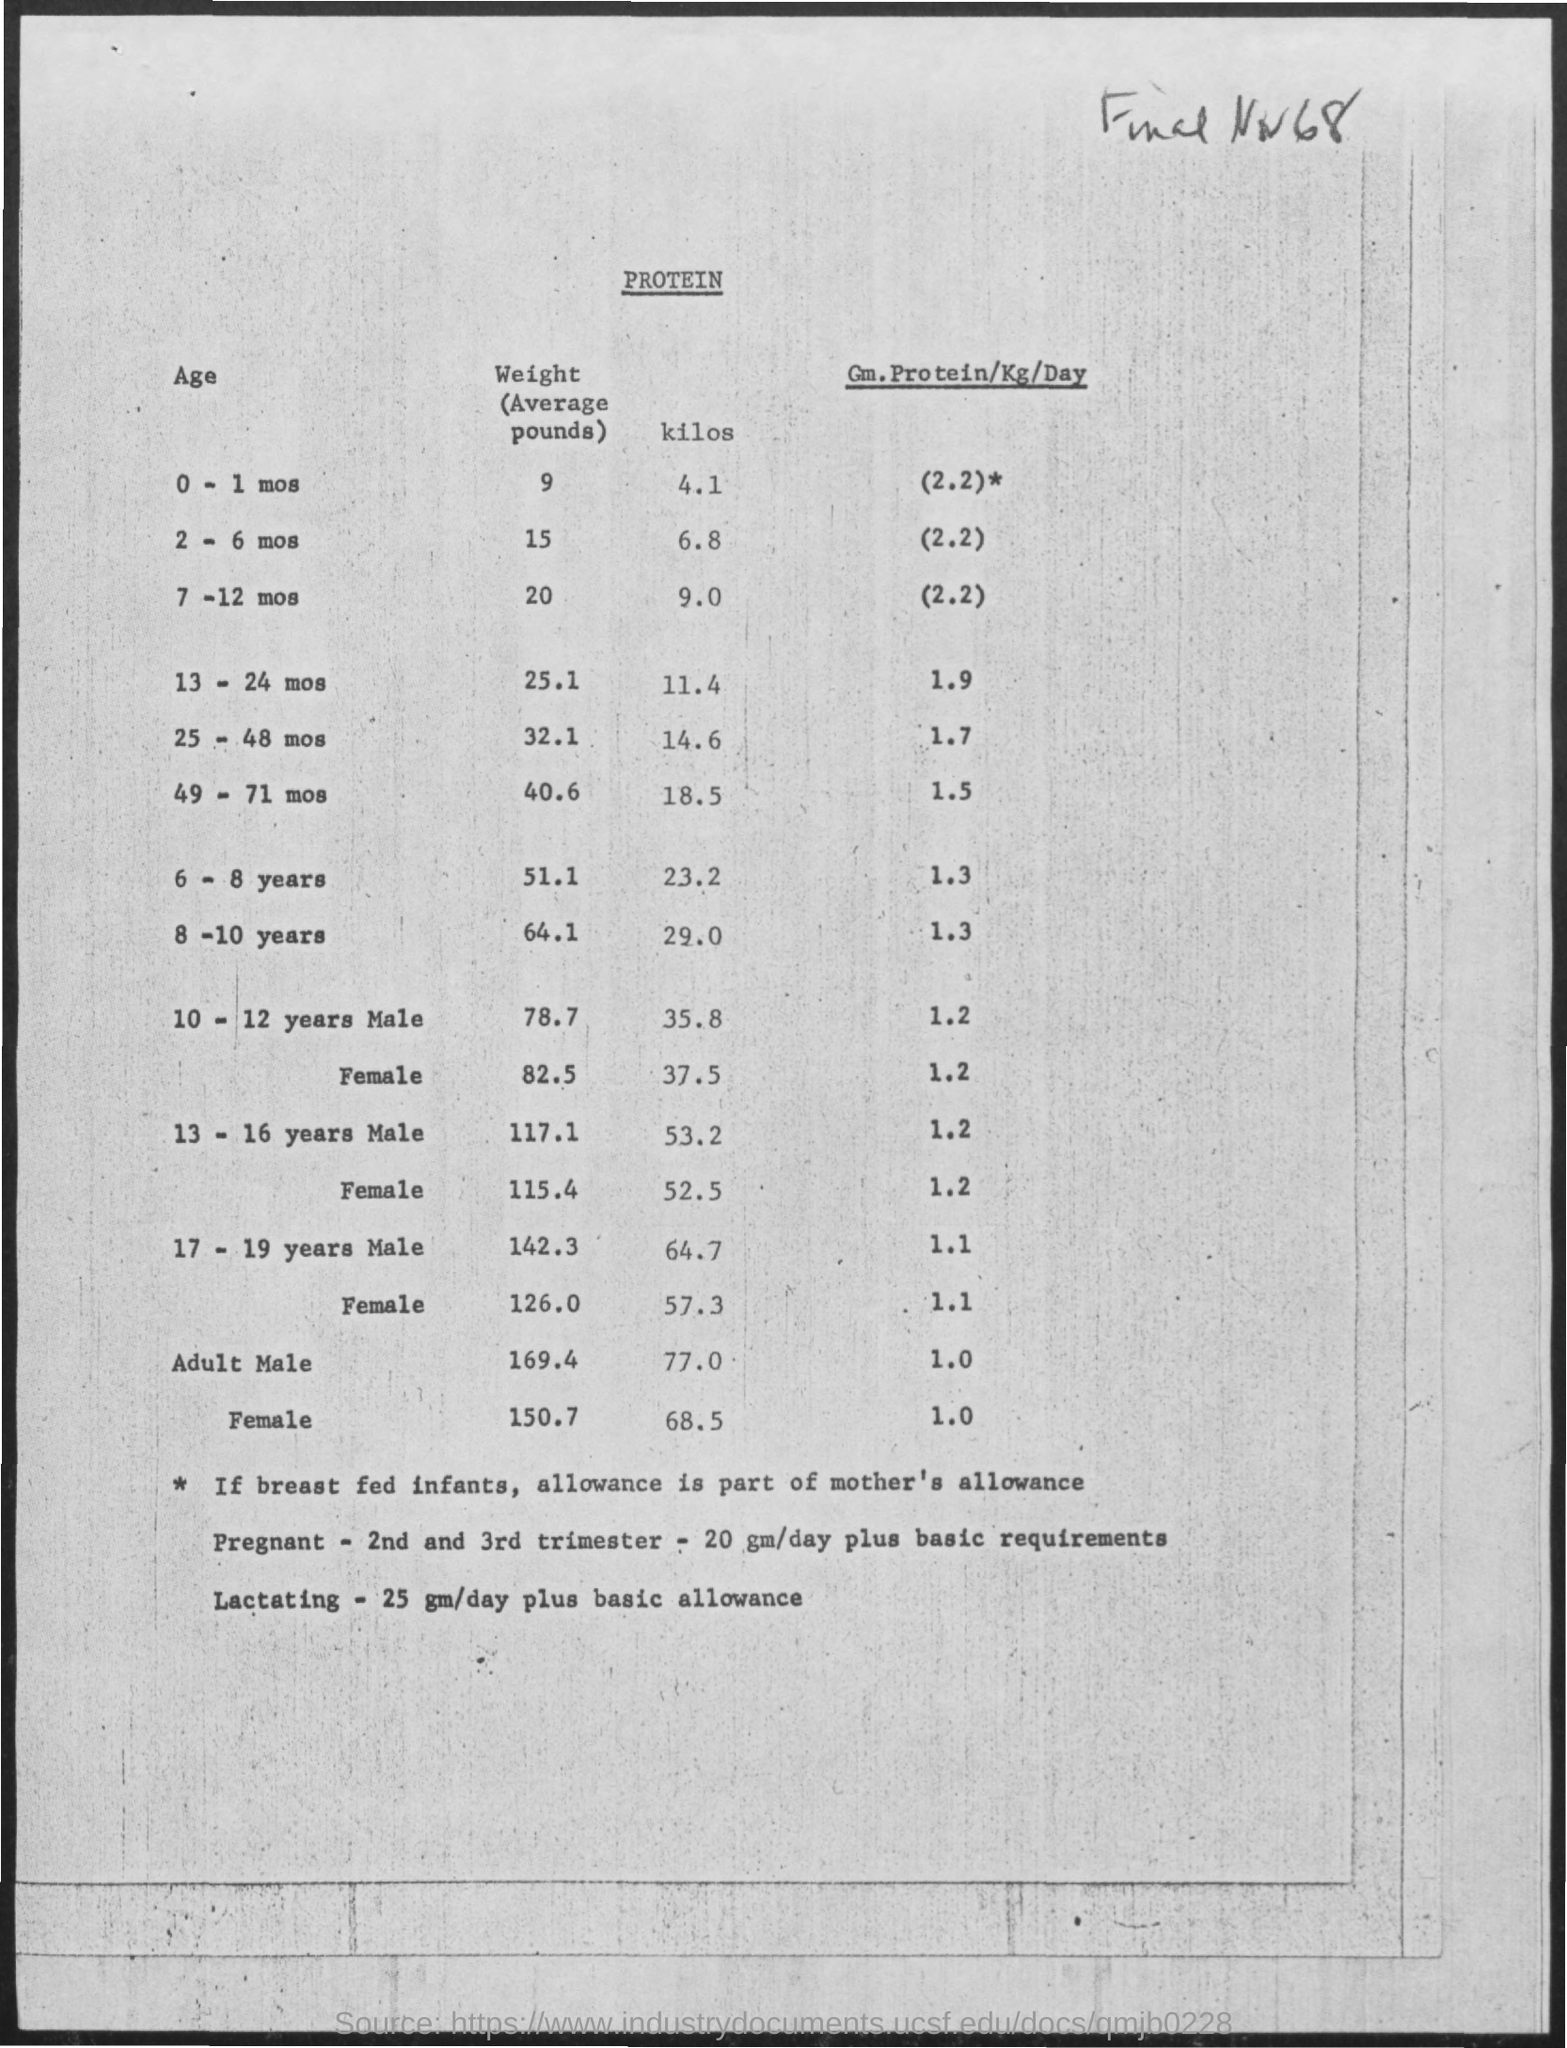What is the average weight in pounds for the age of 2-6 mos. ?
Your answer should be very brief. 15. What is the average weight in pounds for the age of 6-8 years ?
Give a very brief answer. 51.1. What is the average weight in kilos for the age of 7-12 mos.?
Your answer should be compact. 9.0. What is the average weight in pounds for the age of 8-10 years ?
Your response must be concise. 64.1. What is the average weight in kilos for the age of 0-1 mos.?
Make the answer very short. 4.1. 